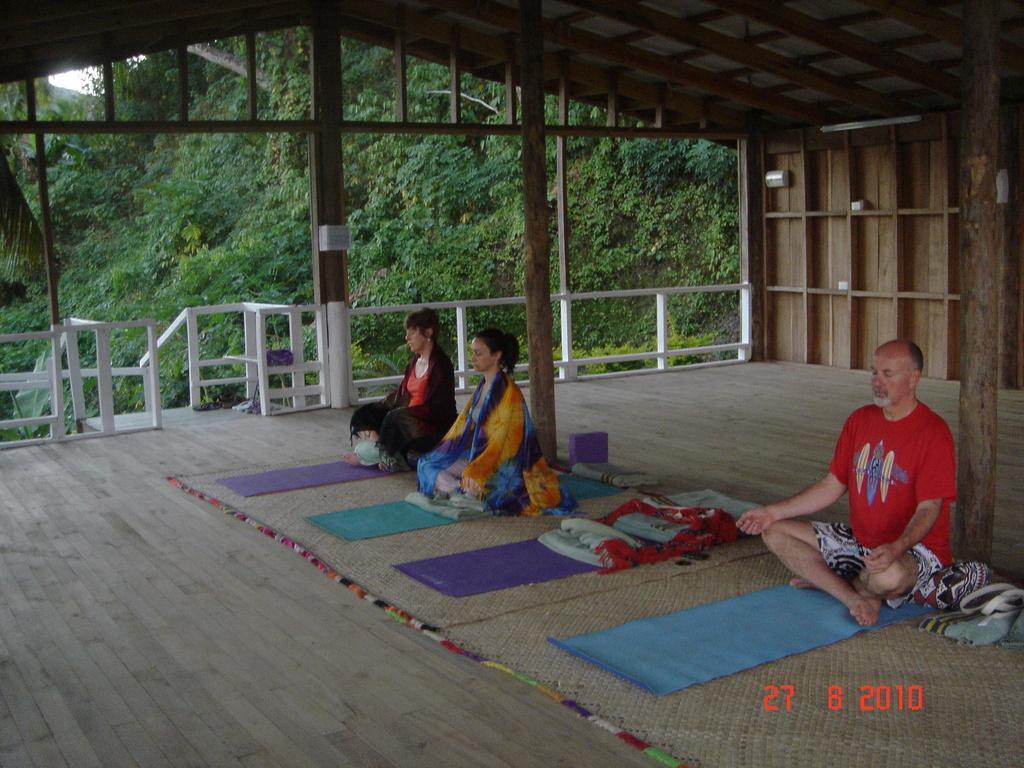Please provide a concise description of this image. In this image there are persons sitting on the mat in the center. In the background there is a railing and there are trees and there are poles in the center and at the bottom of the image there are some numbers. 